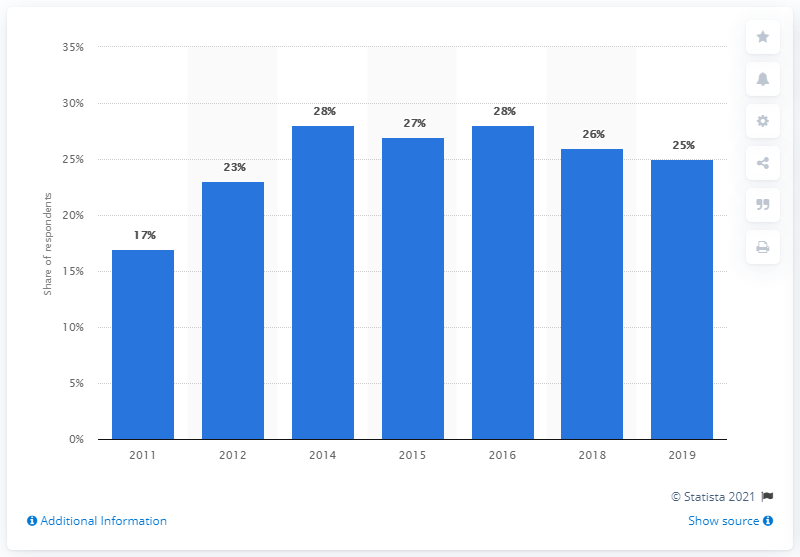Give some essential details in this illustration. E-book consumption stopped growing in 2016. In 2019, approximately 25% of adults in the United States had read an e-book in the previous 12 months. 